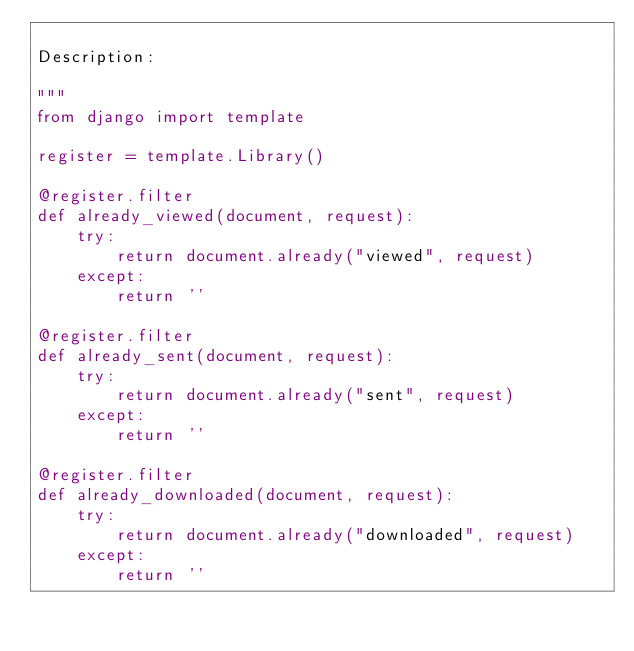Convert code to text. <code><loc_0><loc_0><loc_500><loc_500><_Python_>
Description: 

"""
from django import template

register = template.Library()

@register.filter
def already_viewed(document, request):
    try:
        return document.already("viewed", request)
    except:
        return ''

@register.filter
def already_sent(document, request):
    try:
        return document.already("sent", request)
    except:
        return ''

@register.filter
def already_downloaded(document, request):
    try:
        return document.already("downloaded", request)
    except:
        return ''
</code> 